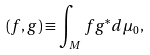<formula> <loc_0><loc_0><loc_500><loc_500>( f , g ) \equiv \int _ { M } f g ^ { * } d \mu _ { 0 } ,</formula> 